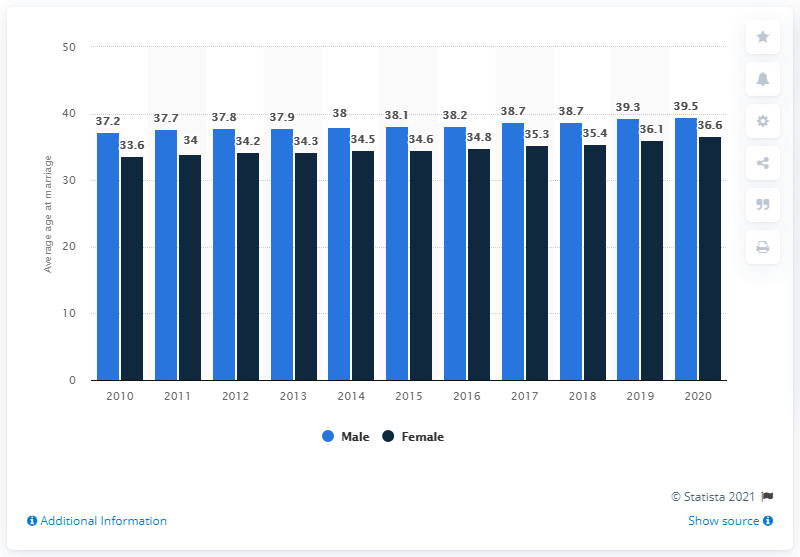Outline some significant characteristics in this image. According to the data, the highest average age of marriage for men was recorded in [year]. The difference between the highest average male marriage age and the minimum average female marriage age over the years is 5.9 years. 